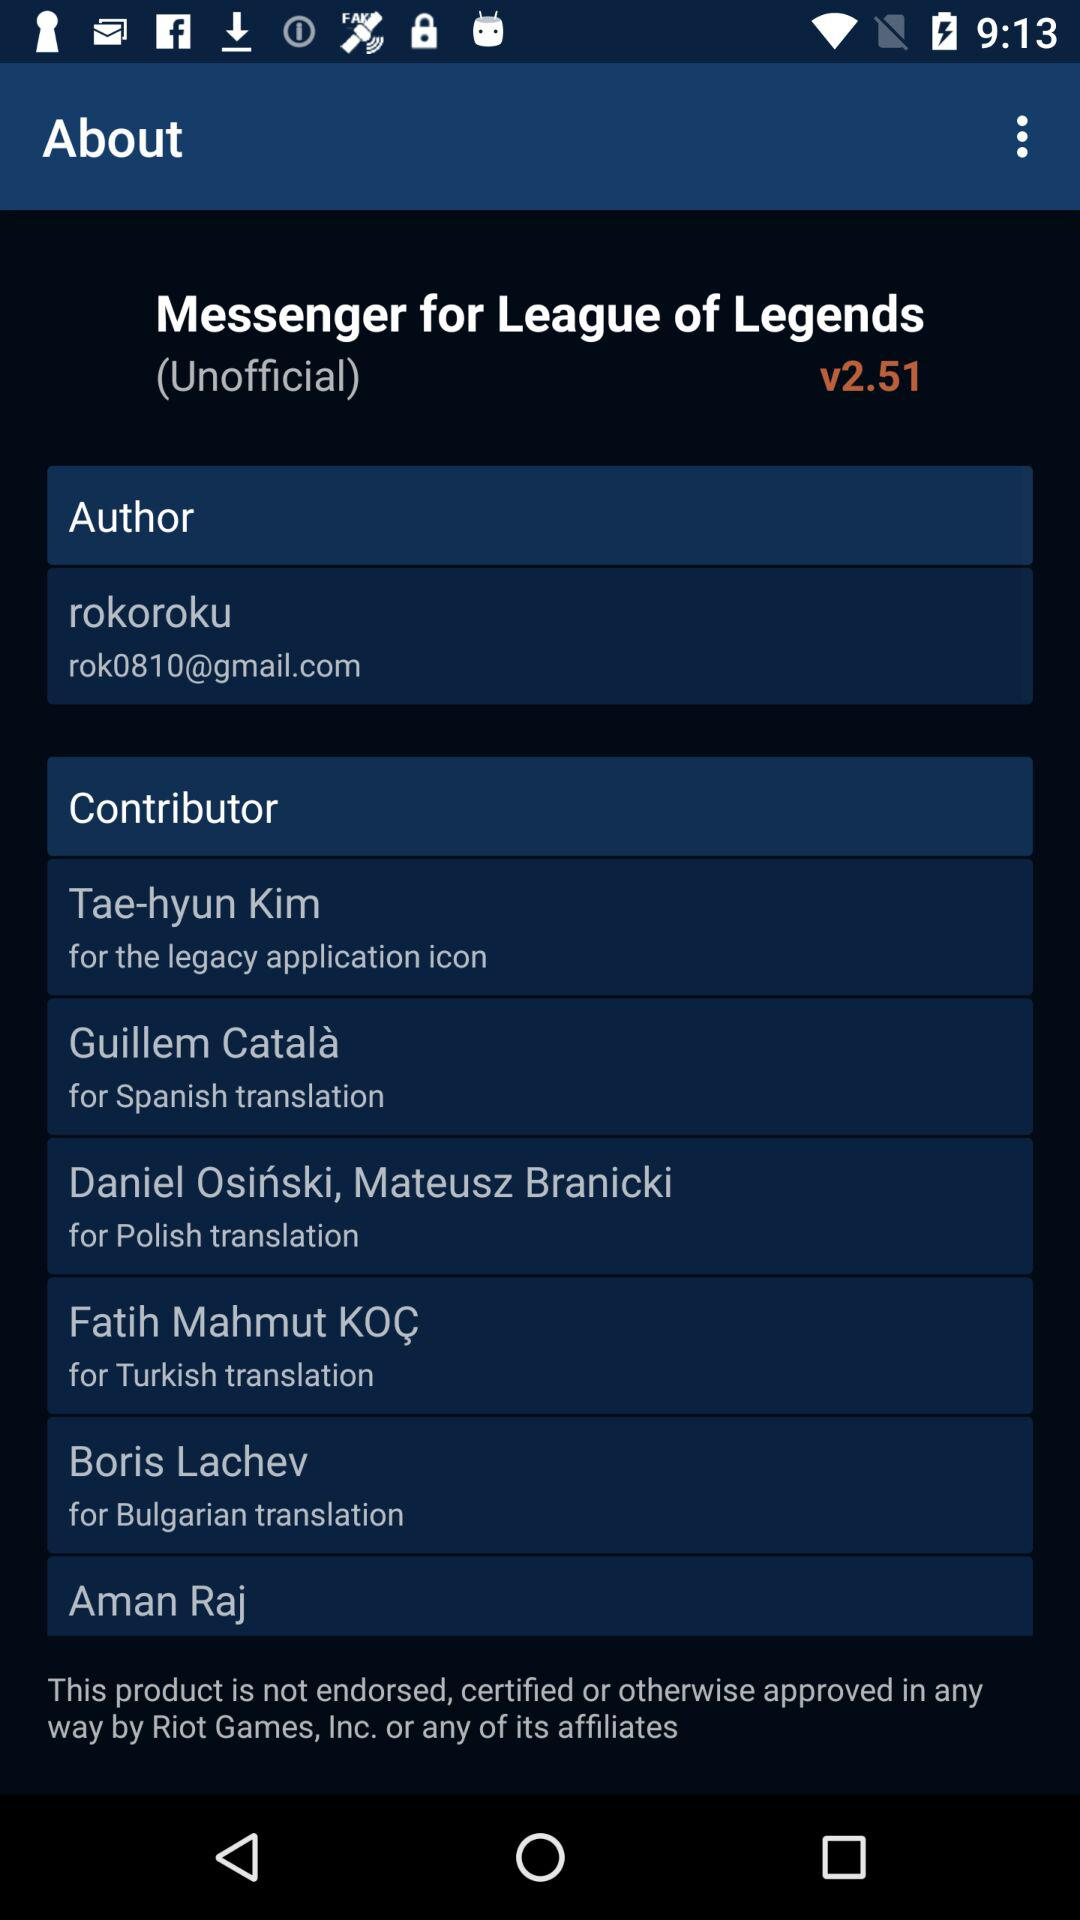What version is it? The version is 2.51. 